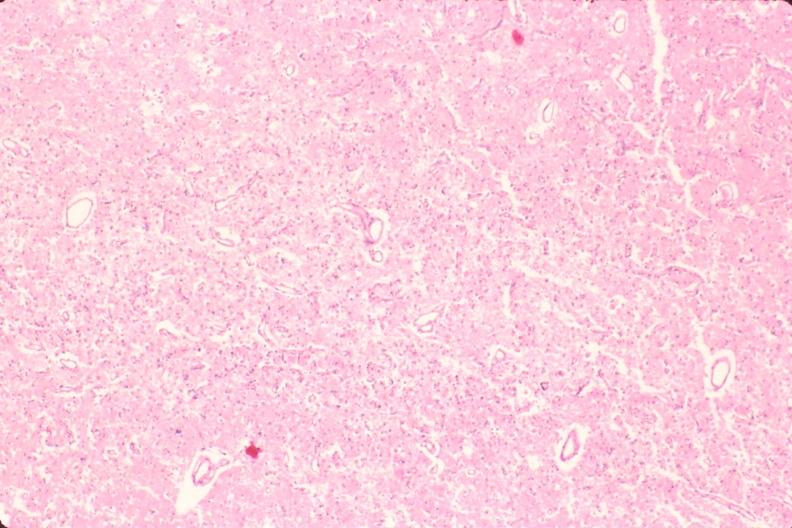where is this?
Answer the question using a single word or phrase. Nervous 